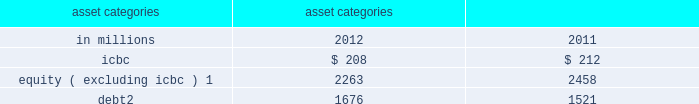Management 2019s discussion and analysis sensitivity measures certain portfolios and individual positions are not included in var because var is not the most appropriate risk measure .
The market risk of these positions is determined by estimating the potential reduction in net revenues of a 10% ( 10 % ) decline in the underlying asset value .
The table below presents market risk for positions that are not included in var .
These measures do not reflect diversification benefits across asset categories and therefore have not been aggregated .
Asset categories 10% ( 10 % ) sensitivity amount as of december in millions 2012 2011 .
Equity ( excluding icbc ) 1 2263 2458 debt 2 1676 1521 1 .
Relates to private and restricted public equity securities , including interests in firm-sponsored funds that invest in corporate equities and real estate and interests in firm-sponsored hedge funds .
Primarily relates to interests in our firm-sponsored funds that invest in corporate mezzanine and senior debt instruments .
Also includes loans backed by commercial and residential real estate , corporate bank loans and other corporate debt , including acquired portfolios of distressed loans .
Var excludes the impact of changes in counterparty and our own credit spreads on derivatives as well as changes in our own credit spreads on unsecured borrowings for which the fair value option was elected .
The estimated sensitivity to a one basis point increase in credit spreads ( counterparty and our own ) on derivatives was a $ 3 million gain ( including hedges ) as of december 2012 .
In addition , the estimated sensitivity to a one basis point increase in our own credit spreads on unsecured borrowings for which the fair value option was elected was a $ 7 million gain ( including hedges ) as of december 2012 .
However , the actual net impact of a change in our own credit spreads is also affected by the liquidity , duration and convexity ( as the sensitivity is not linear to changes in yields ) of those unsecured borrowings for which the fair value option was elected , as well as the relative performance of any hedges undertaken .
The firm engages in insurance activities where we reinsure and purchase portfolios of insurance risk and pension liabilities .
The risks associated with these activities include , but are not limited to : equity price , interest rate , reinvestment and mortality risk .
The firm mitigates risks associated with insurance activities through the use of reinsurance and hedging .
Certain of the assets associated with the firm 2019s insurance activities are included in var .
In addition to the positions included in var , we held $ 9.07 billion of securities accounted for as available-for- sale as of december 2012 , which support the firm 2019s reinsurance business .
As of december 2012 , our available- for-sale securities primarily consisted of $ 3.63 billion of corporate debt securities with an average yield of 4% ( 4 % ) , the majority of which will mature after five years , $ 3.38 billion of mortgage and other asset-backed loans and securities with an average yield of 6% ( 6 % ) , the majority of which will mature after ten years , and $ 856 million of u.s .
Government and federal agency obligations with an average yield of 3% ( 3 % ) , the majority of which will mature after five years .
As of december 2012 , such assets were classified as held for sale and were included in 201cother assets . 201d see note 12 to the consolidated financial statements for further information about assets held for sale .
As of december 2011 , we held $ 4.86 billion of securities accounted for as available-for-sale , primarily consisting of $ 1.81 billion of corporate debt securities with an average yield of 5% ( 5 % ) , the majority of which will mature after five years , $ 1.42 billion of mortgage and other asset-backed loans and securities with an average yield of 10% ( 10 % ) , the majority of which will mature after ten years , and $ 662 million of u.s .
Government and federal agency obligations with an average yield of 3% ( 3 % ) , the majority of which will mature after ten years .
In addition , as of december 2012 and december 2011 , we had commitments and held loans for which we have obtained credit loss protection from sumitomo mitsui financial group , inc .
See note 18 to the consolidated financial statements for further information about such lending commitments .
As of december 2012 , the firm also had $ 6.50 billion of loans held for investment which were accounted for at amortized cost and included in 201creceivables from customers and counterparties , 201d substantially all of which had floating interest rates .
The estimated sensitivity to a 100 basis point increase in interest rates on such loans was $ 62 million of additional interest income over a 12-month period , which does not take into account the potential impact of an increase in costs to fund such loans .
See note 8 to the consolidated financial statements for further information about loans held for investment .
Additionally , we make investments accounted for under the equity method and we also make direct investments in real estate , both of which are included in 201cother assets 201d in the consolidated statements of financial condition .
Direct investments in real estate are accounted for at cost less accumulated depreciation .
See note 12 to the consolidated financial statements for information on 201cother assets . 201d goldman sachs 2012 annual report 93 .
As of december 2012 , what percentage of available- for-sale securities was comprised of mortgage and other asset-backed loans and securities? 
Computations: (3.38 / ((3.63 + 3.38) / (856 / 1000)))
Answer: 0.41274. 